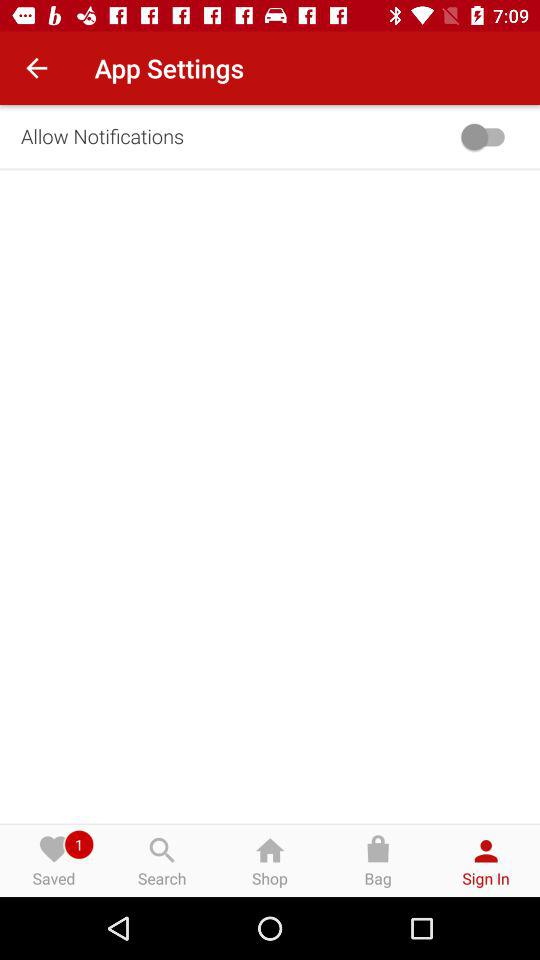Is there any pending notification in "Saved"? There is 1 pending notification in "Saved". 